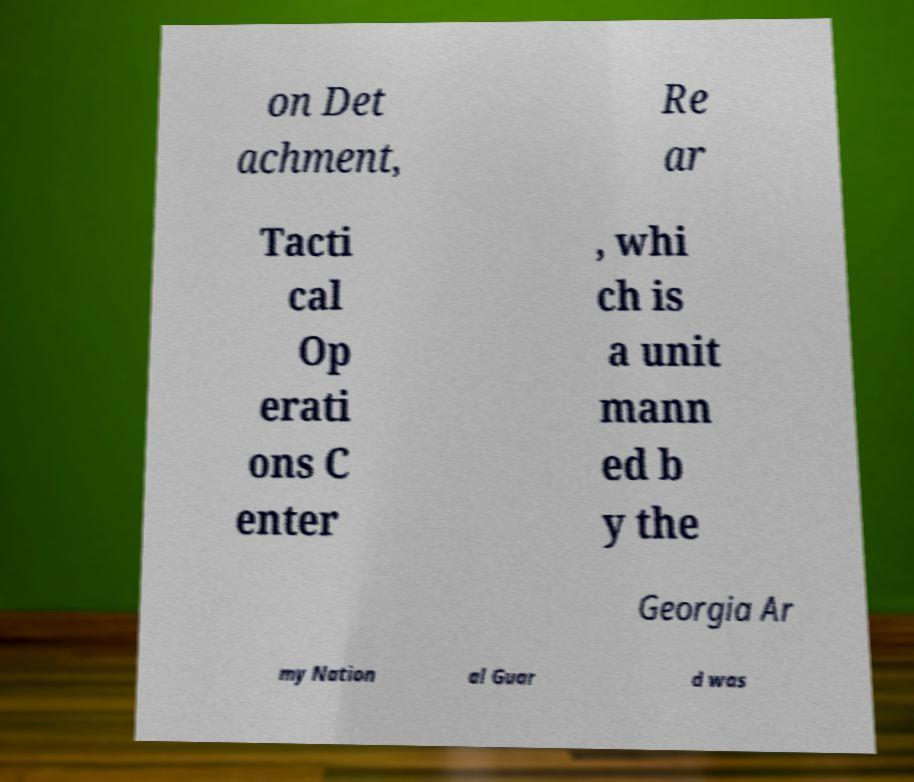What messages or text are displayed in this image? I need them in a readable, typed format. on Det achment, Re ar Tacti cal Op erati ons C enter , whi ch is a unit mann ed b y the Georgia Ar my Nation al Guar d was 